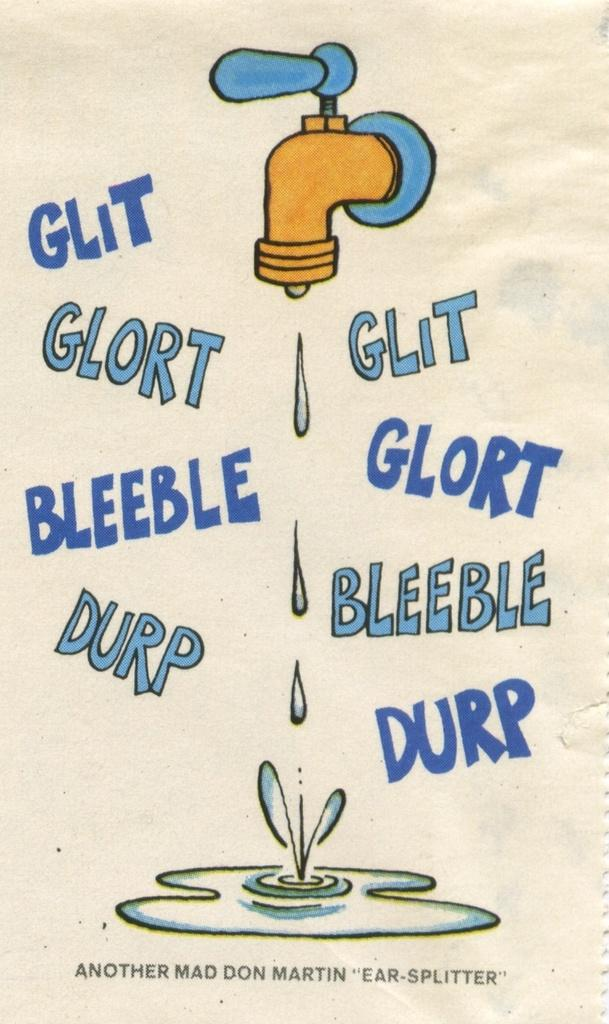<image>
Give a short and clear explanation of the subsequent image. a poster by don martin titled ear splitter 